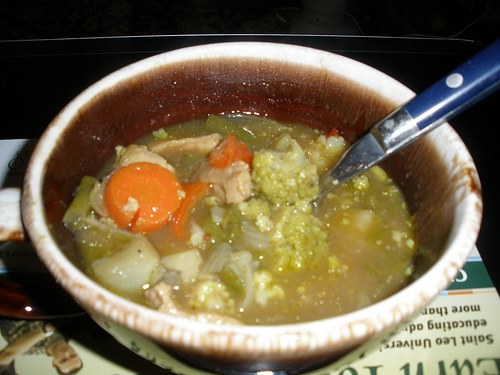Choose one word to describe the image and explain why you chose that word. Comfort. This image evokes a sense of comfort due to the steaming bowl of hearty soup, which is reminiscent of home-cooked meals and the warmth they bring, especially on a cold day. 